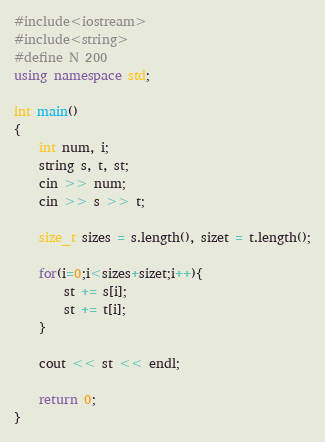Convert code to text. <code><loc_0><loc_0><loc_500><loc_500><_C++_>#include<iostream>
#include<string>
#define N 200
using namespace std;

int main()
{
    int num, i;
    string s, t, st;
    cin >> num;
    cin >> s >> t;

    size_t sizes = s.length(), sizet = t.length();

    for(i=0;i<sizes+sizet;i++){
        st += s[i];
        st += t[i];
    }

    cout << st << endl;

    return 0;
}</code> 